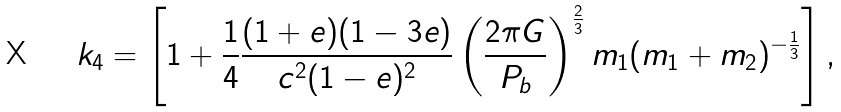<formula> <loc_0><loc_0><loc_500><loc_500>k _ { 4 } = \left [ 1 + \frac { 1 } { 4 } \frac { ( 1 + e ) ( 1 - 3 e ) } { c ^ { 2 } ( 1 - e ) ^ { 2 } } \left ( \frac { 2 \pi G } { P _ { b } } \right ) ^ { \frac { 2 } { 3 } } m _ { 1 } ( m _ { 1 } + m _ { 2 } ) ^ { - \frac { 1 } { 3 } } \right ] ,</formula> 